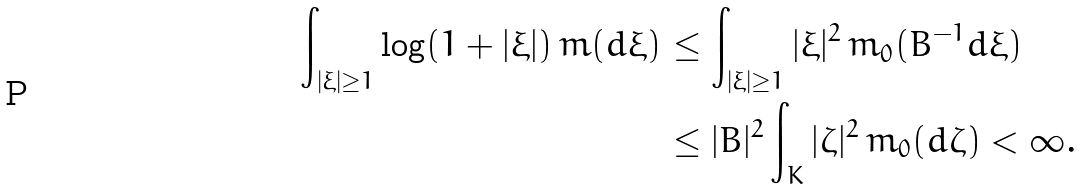<formula> <loc_0><loc_0><loc_500><loc_500>\int _ { | \xi | \geq 1 } \log ( 1 + | \xi | ) \, m ( d \xi ) & \leq \int _ { | \xi | \geq 1 } | \xi | ^ { 2 } \, m _ { 0 } ( B ^ { - 1 } d \xi ) \\ & \leq | B | ^ { 2 } \int _ { K } | \zeta | ^ { 2 } \, m _ { 0 } ( d \zeta ) < \infty .</formula> 